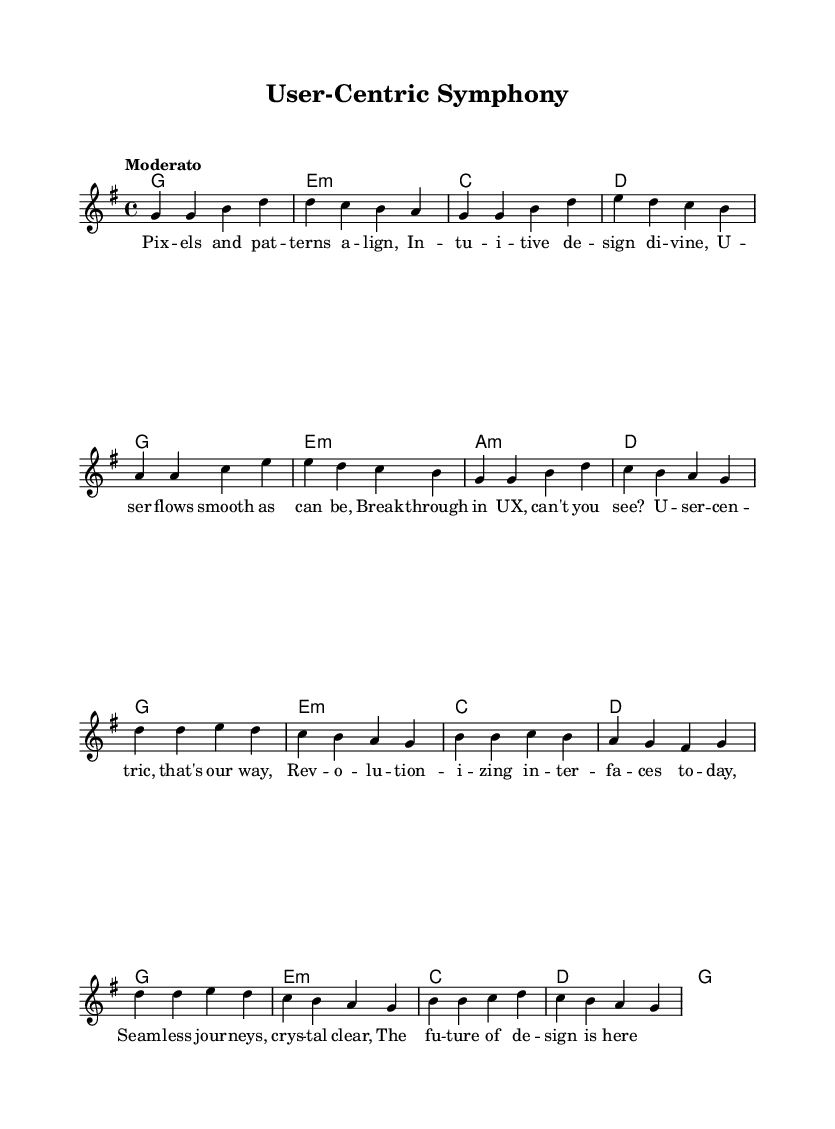What is the key signature of this music? The key signature is G major, indicated by one sharp (F#) in the music.
Answer: G major What is the time signature of this piece? The time signature is 4/4, which means there are four beats in a measure and a quarter note receives one beat.
Answer: 4/4 What is the tempo marking of the piece? The tempo marking is "Moderato", indicating a moderate speed for the performance of the piece.
Answer: Moderato How many measures are in the verse section? The verse section consists of 8 measures as shown by the grouping of notes and chords in the music.
Answer: 8 How many chords are used in the chorus? There are 5 unique chords in the chorus as they appear under the melody, reflecting the harmonic structure specifically for that section.
Answer: 5 What is the primary theme of the lyrics? The lyrics revolve around user experience design breakthroughs, celebrating user-centric design principles through a lyrical format typical of pop ballads.
Answer: User experience How is the structure of this piece typical of pop ballads? The piece follows a common pop ballad structure with a clear verse and chorus format, repetitive themes, and emotional lyrical content, which are hallmarks of the genre.
Answer: Verse-Chorus 